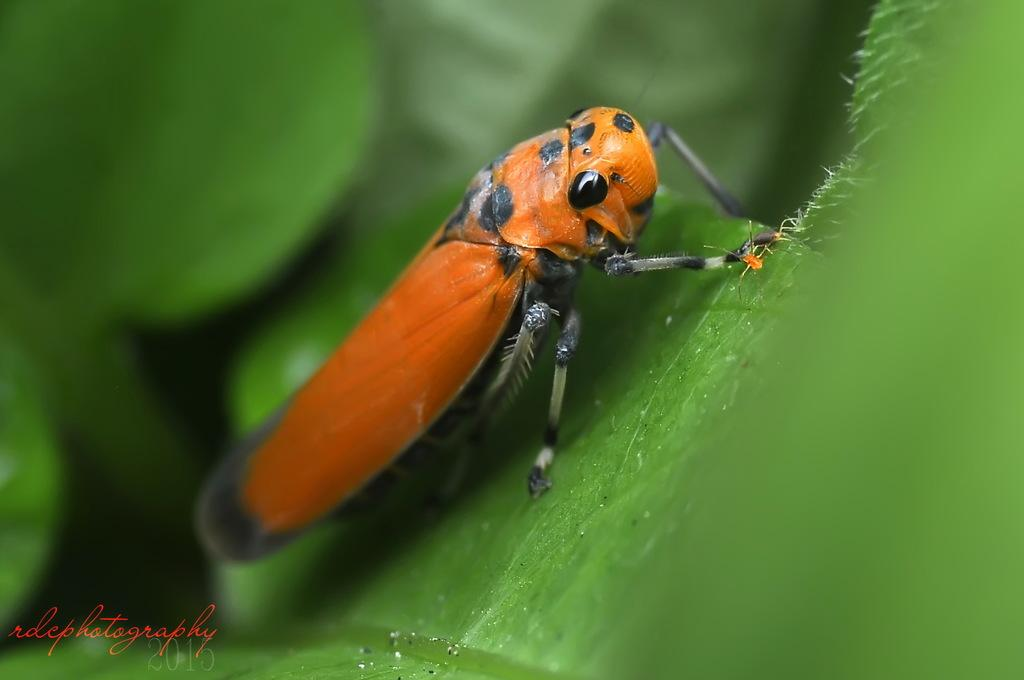What is present on the leaf in the image? There is an insect on a leaf in the image. Can you describe the background of the image? The background of the image is blurry. What type of collar is the insect wearing in the image? There is no collar present on the insect in the image. Is the insect wearing a cap in the image? There is no cap present on the insect in the image. 